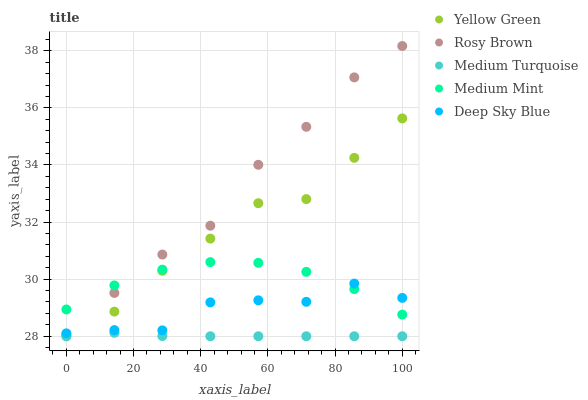Does Medium Turquoise have the minimum area under the curve?
Answer yes or no. Yes. Does Rosy Brown have the maximum area under the curve?
Answer yes or no. Yes. Does Deep Sky Blue have the minimum area under the curve?
Answer yes or no. No. Does Deep Sky Blue have the maximum area under the curve?
Answer yes or no. No. Is Medium Turquoise the smoothest?
Answer yes or no. Yes. Is Deep Sky Blue the roughest?
Answer yes or no. Yes. Is Rosy Brown the smoothest?
Answer yes or no. No. Is Rosy Brown the roughest?
Answer yes or no. No. Does Yellow Green have the lowest value?
Answer yes or no. Yes. Does Deep Sky Blue have the lowest value?
Answer yes or no. No. Does Rosy Brown have the highest value?
Answer yes or no. Yes. Does Deep Sky Blue have the highest value?
Answer yes or no. No. Is Medium Turquoise less than Deep Sky Blue?
Answer yes or no. Yes. Is Medium Mint greater than Medium Turquoise?
Answer yes or no. Yes. Does Medium Mint intersect Deep Sky Blue?
Answer yes or no. Yes. Is Medium Mint less than Deep Sky Blue?
Answer yes or no. No. Is Medium Mint greater than Deep Sky Blue?
Answer yes or no. No. Does Medium Turquoise intersect Deep Sky Blue?
Answer yes or no. No. 